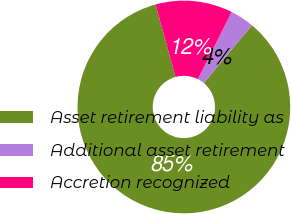Convert chart. <chart><loc_0><loc_0><loc_500><loc_500><pie_chart><fcel>Asset retirement liability as<fcel>Additional asset retirement<fcel>Accretion recognized<nl><fcel>84.66%<fcel>3.62%<fcel>11.72%<nl></chart> 